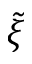<formula> <loc_0><loc_0><loc_500><loc_500>\tilde { \xi }</formula> 